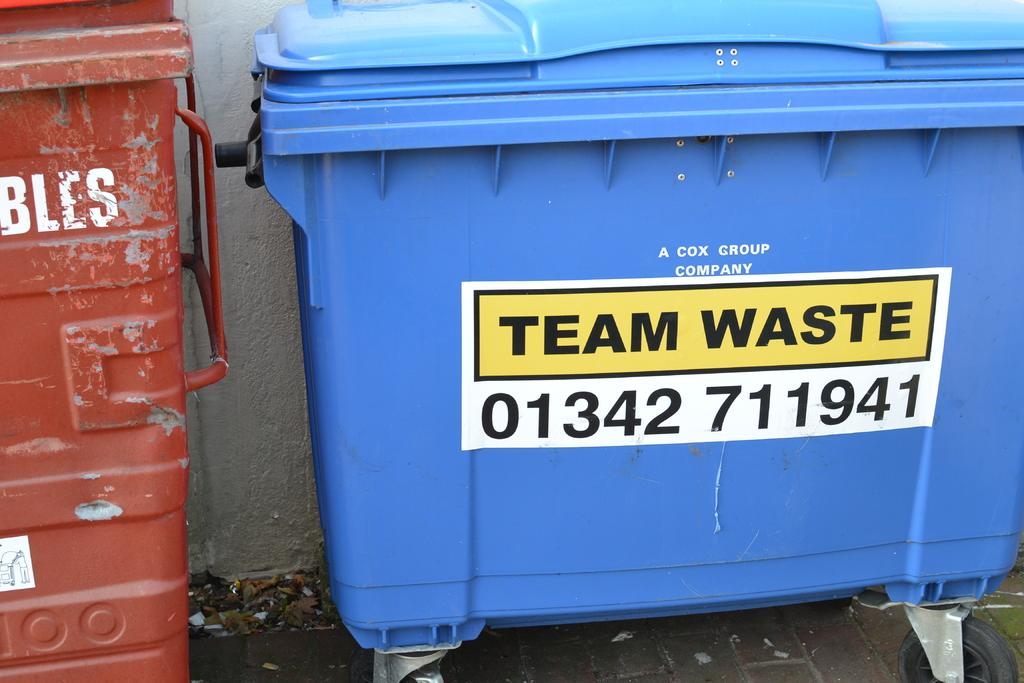What type of containers are present in the image? There are bins in the image. What else can be seen on the wall in the image? There is a poster visible in the image. What is the background of the image composed of? There is a wall visible in the background of the image. What type of drawer is visible in the image? There is no drawer present in the image; only bins and a poster are visible. 